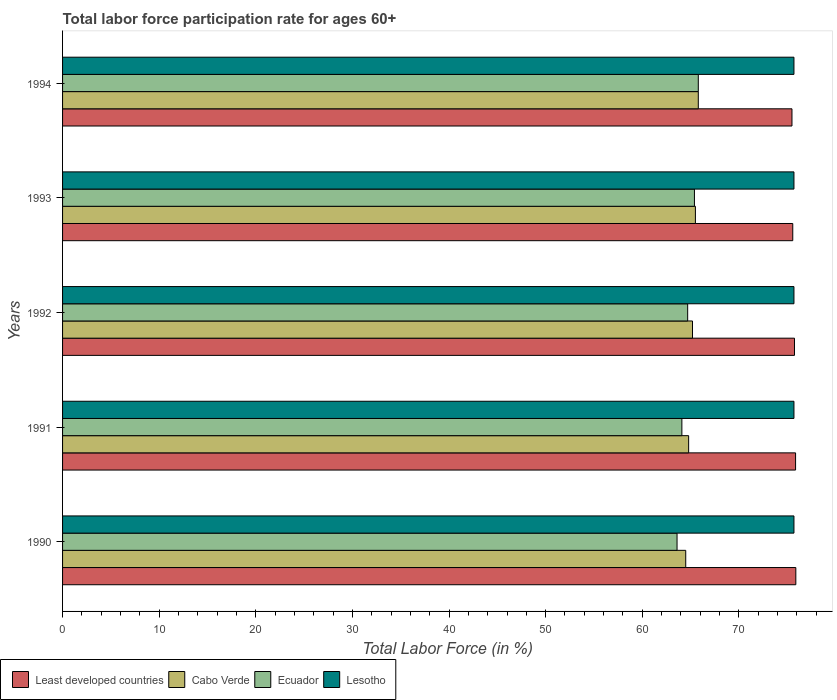How many different coloured bars are there?
Give a very brief answer. 4. How many groups of bars are there?
Your response must be concise. 5. Are the number of bars per tick equal to the number of legend labels?
Give a very brief answer. Yes. How many bars are there on the 1st tick from the top?
Make the answer very short. 4. In how many cases, is the number of bars for a given year not equal to the number of legend labels?
Your answer should be very brief. 0. What is the labor force participation rate in Cabo Verde in 1991?
Your answer should be very brief. 64.8. Across all years, what is the maximum labor force participation rate in Cabo Verde?
Your response must be concise. 65.8. Across all years, what is the minimum labor force participation rate in Lesotho?
Your answer should be very brief. 75.7. In which year was the labor force participation rate in Lesotho maximum?
Your answer should be compact. 1990. In which year was the labor force participation rate in Ecuador minimum?
Offer a very short reply. 1990. What is the total labor force participation rate in Ecuador in the graph?
Your answer should be compact. 323.6. What is the difference between the labor force participation rate in Lesotho in 1991 and that in 1992?
Your answer should be compact. 0. What is the difference between the labor force participation rate in Least developed countries in 1992 and the labor force participation rate in Lesotho in 1991?
Provide a succinct answer. 0.05. What is the average labor force participation rate in Least developed countries per year?
Ensure brevity in your answer.  75.72. In the year 1993, what is the difference between the labor force participation rate in Lesotho and labor force participation rate in Least developed countries?
Offer a very short reply. 0.12. What is the ratio of the labor force participation rate in Ecuador in 1990 to that in 1991?
Offer a very short reply. 0.99. Is the labor force participation rate in Ecuador in 1990 less than that in 1994?
Offer a terse response. Yes. Is the difference between the labor force participation rate in Lesotho in 1991 and 1992 greater than the difference between the labor force participation rate in Least developed countries in 1991 and 1992?
Your answer should be very brief. No. What is the difference between the highest and the second highest labor force participation rate in Ecuador?
Your answer should be very brief. 0.4. What is the difference between the highest and the lowest labor force participation rate in Ecuador?
Offer a very short reply. 2.2. Is it the case that in every year, the sum of the labor force participation rate in Ecuador and labor force participation rate in Least developed countries is greater than the sum of labor force participation rate in Lesotho and labor force participation rate in Cabo Verde?
Your response must be concise. No. What does the 1st bar from the top in 1991 represents?
Provide a succinct answer. Lesotho. What does the 4th bar from the bottom in 1991 represents?
Keep it short and to the point. Lesotho. Is it the case that in every year, the sum of the labor force participation rate in Cabo Verde and labor force participation rate in Least developed countries is greater than the labor force participation rate in Lesotho?
Offer a terse response. Yes. Are all the bars in the graph horizontal?
Give a very brief answer. Yes. How many years are there in the graph?
Provide a short and direct response. 5. What is the difference between two consecutive major ticks on the X-axis?
Offer a terse response. 10. What is the title of the graph?
Provide a short and direct response. Total labor force participation rate for ages 60+. What is the label or title of the Y-axis?
Offer a very short reply. Years. What is the Total Labor Force (in %) of Least developed countries in 1990?
Offer a terse response. 75.89. What is the Total Labor Force (in %) of Cabo Verde in 1990?
Provide a short and direct response. 64.5. What is the Total Labor Force (in %) in Ecuador in 1990?
Your response must be concise. 63.6. What is the Total Labor Force (in %) in Lesotho in 1990?
Your answer should be very brief. 75.7. What is the Total Labor Force (in %) in Least developed countries in 1991?
Give a very brief answer. 75.87. What is the Total Labor Force (in %) in Cabo Verde in 1991?
Provide a succinct answer. 64.8. What is the Total Labor Force (in %) of Ecuador in 1991?
Keep it short and to the point. 64.1. What is the Total Labor Force (in %) of Lesotho in 1991?
Make the answer very short. 75.7. What is the Total Labor Force (in %) of Least developed countries in 1992?
Offer a terse response. 75.75. What is the Total Labor Force (in %) in Cabo Verde in 1992?
Your answer should be compact. 65.2. What is the Total Labor Force (in %) of Ecuador in 1992?
Your response must be concise. 64.7. What is the Total Labor Force (in %) in Lesotho in 1992?
Make the answer very short. 75.7. What is the Total Labor Force (in %) of Least developed countries in 1993?
Make the answer very short. 75.58. What is the Total Labor Force (in %) of Cabo Verde in 1993?
Make the answer very short. 65.5. What is the Total Labor Force (in %) of Ecuador in 1993?
Offer a terse response. 65.4. What is the Total Labor Force (in %) of Lesotho in 1993?
Provide a succinct answer. 75.7. What is the Total Labor Force (in %) in Least developed countries in 1994?
Your response must be concise. 75.49. What is the Total Labor Force (in %) of Cabo Verde in 1994?
Provide a short and direct response. 65.8. What is the Total Labor Force (in %) in Ecuador in 1994?
Keep it short and to the point. 65.8. What is the Total Labor Force (in %) of Lesotho in 1994?
Make the answer very short. 75.7. Across all years, what is the maximum Total Labor Force (in %) in Least developed countries?
Keep it short and to the point. 75.89. Across all years, what is the maximum Total Labor Force (in %) in Cabo Verde?
Your answer should be compact. 65.8. Across all years, what is the maximum Total Labor Force (in %) of Ecuador?
Provide a succinct answer. 65.8. Across all years, what is the maximum Total Labor Force (in %) in Lesotho?
Offer a terse response. 75.7. Across all years, what is the minimum Total Labor Force (in %) of Least developed countries?
Provide a short and direct response. 75.49. Across all years, what is the minimum Total Labor Force (in %) of Cabo Verde?
Keep it short and to the point. 64.5. Across all years, what is the minimum Total Labor Force (in %) in Ecuador?
Provide a succinct answer. 63.6. Across all years, what is the minimum Total Labor Force (in %) of Lesotho?
Ensure brevity in your answer.  75.7. What is the total Total Labor Force (in %) in Least developed countries in the graph?
Your answer should be compact. 378.59. What is the total Total Labor Force (in %) of Cabo Verde in the graph?
Your answer should be very brief. 325.8. What is the total Total Labor Force (in %) in Ecuador in the graph?
Offer a terse response. 323.6. What is the total Total Labor Force (in %) of Lesotho in the graph?
Offer a terse response. 378.5. What is the difference between the Total Labor Force (in %) in Least developed countries in 1990 and that in 1991?
Provide a succinct answer. 0.03. What is the difference between the Total Labor Force (in %) in Cabo Verde in 1990 and that in 1991?
Keep it short and to the point. -0.3. What is the difference between the Total Labor Force (in %) of Least developed countries in 1990 and that in 1992?
Your response must be concise. 0.14. What is the difference between the Total Labor Force (in %) in Ecuador in 1990 and that in 1992?
Provide a short and direct response. -1.1. What is the difference between the Total Labor Force (in %) in Lesotho in 1990 and that in 1992?
Provide a short and direct response. 0. What is the difference between the Total Labor Force (in %) in Least developed countries in 1990 and that in 1993?
Ensure brevity in your answer.  0.32. What is the difference between the Total Labor Force (in %) of Lesotho in 1990 and that in 1993?
Give a very brief answer. 0. What is the difference between the Total Labor Force (in %) of Cabo Verde in 1990 and that in 1994?
Keep it short and to the point. -1.3. What is the difference between the Total Labor Force (in %) of Least developed countries in 1991 and that in 1992?
Your response must be concise. 0.11. What is the difference between the Total Labor Force (in %) in Cabo Verde in 1991 and that in 1992?
Provide a short and direct response. -0.4. What is the difference between the Total Labor Force (in %) in Lesotho in 1991 and that in 1992?
Your answer should be very brief. 0. What is the difference between the Total Labor Force (in %) in Least developed countries in 1991 and that in 1993?
Your answer should be very brief. 0.29. What is the difference between the Total Labor Force (in %) in Ecuador in 1991 and that in 1993?
Give a very brief answer. -1.3. What is the difference between the Total Labor Force (in %) in Least developed countries in 1991 and that in 1994?
Offer a very short reply. 0.37. What is the difference between the Total Labor Force (in %) of Least developed countries in 1992 and that in 1993?
Ensure brevity in your answer.  0.18. What is the difference between the Total Labor Force (in %) of Least developed countries in 1992 and that in 1994?
Your response must be concise. 0.26. What is the difference between the Total Labor Force (in %) of Ecuador in 1992 and that in 1994?
Ensure brevity in your answer.  -1.1. What is the difference between the Total Labor Force (in %) in Lesotho in 1992 and that in 1994?
Provide a succinct answer. 0. What is the difference between the Total Labor Force (in %) of Least developed countries in 1993 and that in 1994?
Keep it short and to the point. 0.08. What is the difference between the Total Labor Force (in %) of Cabo Verde in 1993 and that in 1994?
Offer a terse response. -0.3. What is the difference between the Total Labor Force (in %) of Ecuador in 1993 and that in 1994?
Your response must be concise. -0.4. What is the difference between the Total Labor Force (in %) in Lesotho in 1993 and that in 1994?
Give a very brief answer. 0. What is the difference between the Total Labor Force (in %) of Least developed countries in 1990 and the Total Labor Force (in %) of Cabo Verde in 1991?
Provide a succinct answer. 11.09. What is the difference between the Total Labor Force (in %) in Least developed countries in 1990 and the Total Labor Force (in %) in Ecuador in 1991?
Provide a succinct answer. 11.79. What is the difference between the Total Labor Force (in %) of Least developed countries in 1990 and the Total Labor Force (in %) of Lesotho in 1991?
Give a very brief answer. 0.19. What is the difference between the Total Labor Force (in %) of Cabo Verde in 1990 and the Total Labor Force (in %) of Lesotho in 1991?
Give a very brief answer. -11.2. What is the difference between the Total Labor Force (in %) of Ecuador in 1990 and the Total Labor Force (in %) of Lesotho in 1991?
Offer a terse response. -12.1. What is the difference between the Total Labor Force (in %) of Least developed countries in 1990 and the Total Labor Force (in %) of Cabo Verde in 1992?
Make the answer very short. 10.69. What is the difference between the Total Labor Force (in %) of Least developed countries in 1990 and the Total Labor Force (in %) of Ecuador in 1992?
Provide a succinct answer. 11.19. What is the difference between the Total Labor Force (in %) of Least developed countries in 1990 and the Total Labor Force (in %) of Lesotho in 1992?
Your answer should be compact. 0.19. What is the difference between the Total Labor Force (in %) of Cabo Verde in 1990 and the Total Labor Force (in %) of Lesotho in 1992?
Make the answer very short. -11.2. What is the difference between the Total Labor Force (in %) of Ecuador in 1990 and the Total Labor Force (in %) of Lesotho in 1992?
Give a very brief answer. -12.1. What is the difference between the Total Labor Force (in %) of Least developed countries in 1990 and the Total Labor Force (in %) of Cabo Verde in 1993?
Your answer should be very brief. 10.39. What is the difference between the Total Labor Force (in %) in Least developed countries in 1990 and the Total Labor Force (in %) in Ecuador in 1993?
Provide a short and direct response. 10.49. What is the difference between the Total Labor Force (in %) of Least developed countries in 1990 and the Total Labor Force (in %) of Lesotho in 1993?
Offer a very short reply. 0.19. What is the difference between the Total Labor Force (in %) in Cabo Verde in 1990 and the Total Labor Force (in %) in Ecuador in 1993?
Your response must be concise. -0.9. What is the difference between the Total Labor Force (in %) in Cabo Verde in 1990 and the Total Labor Force (in %) in Lesotho in 1993?
Offer a very short reply. -11.2. What is the difference between the Total Labor Force (in %) in Least developed countries in 1990 and the Total Labor Force (in %) in Cabo Verde in 1994?
Give a very brief answer. 10.09. What is the difference between the Total Labor Force (in %) in Least developed countries in 1990 and the Total Labor Force (in %) in Ecuador in 1994?
Ensure brevity in your answer.  10.09. What is the difference between the Total Labor Force (in %) of Least developed countries in 1990 and the Total Labor Force (in %) of Lesotho in 1994?
Give a very brief answer. 0.19. What is the difference between the Total Labor Force (in %) in Cabo Verde in 1990 and the Total Labor Force (in %) in Lesotho in 1994?
Offer a terse response. -11.2. What is the difference between the Total Labor Force (in %) in Least developed countries in 1991 and the Total Labor Force (in %) in Cabo Verde in 1992?
Give a very brief answer. 10.67. What is the difference between the Total Labor Force (in %) in Least developed countries in 1991 and the Total Labor Force (in %) in Ecuador in 1992?
Offer a very short reply. 11.17. What is the difference between the Total Labor Force (in %) of Least developed countries in 1991 and the Total Labor Force (in %) of Lesotho in 1992?
Provide a succinct answer. 0.17. What is the difference between the Total Labor Force (in %) in Cabo Verde in 1991 and the Total Labor Force (in %) in Lesotho in 1992?
Offer a very short reply. -10.9. What is the difference between the Total Labor Force (in %) of Least developed countries in 1991 and the Total Labor Force (in %) of Cabo Verde in 1993?
Your response must be concise. 10.37. What is the difference between the Total Labor Force (in %) in Least developed countries in 1991 and the Total Labor Force (in %) in Ecuador in 1993?
Give a very brief answer. 10.47. What is the difference between the Total Labor Force (in %) in Least developed countries in 1991 and the Total Labor Force (in %) in Lesotho in 1993?
Give a very brief answer. 0.17. What is the difference between the Total Labor Force (in %) of Cabo Verde in 1991 and the Total Labor Force (in %) of Lesotho in 1993?
Make the answer very short. -10.9. What is the difference between the Total Labor Force (in %) of Least developed countries in 1991 and the Total Labor Force (in %) of Cabo Verde in 1994?
Offer a very short reply. 10.07. What is the difference between the Total Labor Force (in %) of Least developed countries in 1991 and the Total Labor Force (in %) of Ecuador in 1994?
Offer a terse response. 10.07. What is the difference between the Total Labor Force (in %) of Least developed countries in 1991 and the Total Labor Force (in %) of Lesotho in 1994?
Provide a short and direct response. 0.17. What is the difference between the Total Labor Force (in %) of Cabo Verde in 1991 and the Total Labor Force (in %) of Ecuador in 1994?
Offer a very short reply. -1. What is the difference between the Total Labor Force (in %) in Least developed countries in 1992 and the Total Labor Force (in %) in Cabo Verde in 1993?
Your response must be concise. 10.25. What is the difference between the Total Labor Force (in %) of Least developed countries in 1992 and the Total Labor Force (in %) of Ecuador in 1993?
Make the answer very short. 10.35. What is the difference between the Total Labor Force (in %) in Least developed countries in 1992 and the Total Labor Force (in %) in Lesotho in 1993?
Provide a succinct answer. 0.05. What is the difference between the Total Labor Force (in %) of Cabo Verde in 1992 and the Total Labor Force (in %) of Lesotho in 1993?
Your answer should be compact. -10.5. What is the difference between the Total Labor Force (in %) of Least developed countries in 1992 and the Total Labor Force (in %) of Cabo Verde in 1994?
Your answer should be very brief. 9.95. What is the difference between the Total Labor Force (in %) in Least developed countries in 1992 and the Total Labor Force (in %) in Ecuador in 1994?
Offer a very short reply. 9.95. What is the difference between the Total Labor Force (in %) of Least developed countries in 1992 and the Total Labor Force (in %) of Lesotho in 1994?
Provide a succinct answer. 0.05. What is the difference between the Total Labor Force (in %) in Cabo Verde in 1992 and the Total Labor Force (in %) in Ecuador in 1994?
Your answer should be compact. -0.6. What is the difference between the Total Labor Force (in %) in Cabo Verde in 1992 and the Total Labor Force (in %) in Lesotho in 1994?
Your answer should be very brief. -10.5. What is the difference between the Total Labor Force (in %) in Ecuador in 1992 and the Total Labor Force (in %) in Lesotho in 1994?
Your response must be concise. -11. What is the difference between the Total Labor Force (in %) in Least developed countries in 1993 and the Total Labor Force (in %) in Cabo Verde in 1994?
Offer a very short reply. 9.78. What is the difference between the Total Labor Force (in %) of Least developed countries in 1993 and the Total Labor Force (in %) of Ecuador in 1994?
Keep it short and to the point. 9.78. What is the difference between the Total Labor Force (in %) in Least developed countries in 1993 and the Total Labor Force (in %) in Lesotho in 1994?
Give a very brief answer. -0.12. What is the difference between the Total Labor Force (in %) in Cabo Verde in 1993 and the Total Labor Force (in %) in Ecuador in 1994?
Make the answer very short. -0.3. What is the difference between the Total Labor Force (in %) of Ecuador in 1993 and the Total Labor Force (in %) of Lesotho in 1994?
Your answer should be compact. -10.3. What is the average Total Labor Force (in %) in Least developed countries per year?
Provide a short and direct response. 75.72. What is the average Total Labor Force (in %) of Cabo Verde per year?
Provide a succinct answer. 65.16. What is the average Total Labor Force (in %) in Ecuador per year?
Your answer should be compact. 64.72. What is the average Total Labor Force (in %) of Lesotho per year?
Make the answer very short. 75.7. In the year 1990, what is the difference between the Total Labor Force (in %) in Least developed countries and Total Labor Force (in %) in Cabo Verde?
Make the answer very short. 11.39. In the year 1990, what is the difference between the Total Labor Force (in %) of Least developed countries and Total Labor Force (in %) of Ecuador?
Your answer should be compact. 12.29. In the year 1990, what is the difference between the Total Labor Force (in %) in Least developed countries and Total Labor Force (in %) in Lesotho?
Give a very brief answer. 0.19. In the year 1990, what is the difference between the Total Labor Force (in %) in Cabo Verde and Total Labor Force (in %) in Ecuador?
Provide a short and direct response. 0.9. In the year 1991, what is the difference between the Total Labor Force (in %) of Least developed countries and Total Labor Force (in %) of Cabo Verde?
Give a very brief answer. 11.07. In the year 1991, what is the difference between the Total Labor Force (in %) in Least developed countries and Total Labor Force (in %) in Ecuador?
Offer a terse response. 11.77. In the year 1991, what is the difference between the Total Labor Force (in %) in Least developed countries and Total Labor Force (in %) in Lesotho?
Ensure brevity in your answer.  0.17. In the year 1991, what is the difference between the Total Labor Force (in %) of Cabo Verde and Total Labor Force (in %) of Ecuador?
Make the answer very short. 0.7. In the year 1992, what is the difference between the Total Labor Force (in %) of Least developed countries and Total Labor Force (in %) of Cabo Verde?
Keep it short and to the point. 10.55. In the year 1992, what is the difference between the Total Labor Force (in %) of Least developed countries and Total Labor Force (in %) of Ecuador?
Provide a short and direct response. 11.05. In the year 1992, what is the difference between the Total Labor Force (in %) in Least developed countries and Total Labor Force (in %) in Lesotho?
Ensure brevity in your answer.  0.05. In the year 1993, what is the difference between the Total Labor Force (in %) of Least developed countries and Total Labor Force (in %) of Cabo Verde?
Give a very brief answer. 10.08. In the year 1993, what is the difference between the Total Labor Force (in %) in Least developed countries and Total Labor Force (in %) in Ecuador?
Make the answer very short. 10.18. In the year 1993, what is the difference between the Total Labor Force (in %) in Least developed countries and Total Labor Force (in %) in Lesotho?
Provide a succinct answer. -0.12. In the year 1994, what is the difference between the Total Labor Force (in %) in Least developed countries and Total Labor Force (in %) in Cabo Verde?
Provide a succinct answer. 9.69. In the year 1994, what is the difference between the Total Labor Force (in %) in Least developed countries and Total Labor Force (in %) in Ecuador?
Provide a succinct answer. 9.69. In the year 1994, what is the difference between the Total Labor Force (in %) of Least developed countries and Total Labor Force (in %) of Lesotho?
Make the answer very short. -0.21. In the year 1994, what is the difference between the Total Labor Force (in %) of Cabo Verde and Total Labor Force (in %) of Ecuador?
Provide a short and direct response. 0. In the year 1994, what is the difference between the Total Labor Force (in %) in Cabo Verde and Total Labor Force (in %) in Lesotho?
Your answer should be very brief. -9.9. What is the ratio of the Total Labor Force (in %) in Least developed countries in 1990 to that in 1991?
Your answer should be compact. 1. What is the ratio of the Total Labor Force (in %) in Cabo Verde in 1990 to that in 1991?
Give a very brief answer. 1. What is the ratio of the Total Labor Force (in %) of Lesotho in 1990 to that in 1991?
Ensure brevity in your answer.  1. What is the ratio of the Total Labor Force (in %) of Least developed countries in 1990 to that in 1992?
Provide a short and direct response. 1. What is the ratio of the Total Labor Force (in %) of Cabo Verde in 1990 to that in 1992?
Ensure brevity in your answer.  0.99. What is the ratio of the Total Labor Force (in %) in Lesotho in 1990 to that in 1992?
Your answer should be very brief. 1. What is the ratio of the Total Labor Force (in %) in Cabo Verde in 1990 to that in 1993?
Ensure brevity in your answer.  0.98. What is the ratio of the Total Labor Force (in %) of Ecuador in 1990 to that in 1993?
Provide a short and direct response. 0.97. What is the ratio of the Total Labor Force (in %) of Lesotho in 1990 to that in 1993?
Your response must be concise. 1. What is the ratio of the Total Labor Force (in %) in Least developed countries in 1990 to that in 1994?
Ensure brevity in your answer.  1.01. What is the ratio of the Total Labor Force (in %) in Cabo Verde in 1990 to that in 1994?
Make the answer very short. 0.98. What is the ratio of the Total Labor Force (in %) of Ecuador in 1990 to that in 1994?
Provide a succinct answer. 0.97. What is the ratio of the Total Labor Force (in %) in Lesotho in 1990 to that in 1994?
Offer a very short reply. 1. What is the ratio of the Total Labor Force (in %) in Cabo Verde in 1991 to that in 1992?
Give a very brief answer. 0.99. What is the ratio of the Total Labor Force (in %) in Lesotho in 1991 to that in 1992?
Make the answer very short. 1. What is the ratio of the Total Labor Force (in %) of Cabo Verde in 1991 to that in 1993?
Keep it short and to the point. 0.99. What is the ratio of the Total Labor Force (in %) in Ecuador in 1991 to that in 1993?
Your answer should be very brief. 0.98. What is the ratio of the Total Labor Force (in %) of Lesotho in 1991 to that in 1993?
Your answer should be compact. 1. What is the ratio of the Total Labor Force (in %) of Ecuador in 1991 to that in 1994?
Keep it short and to the point. 0.97. What is the ratio of the Total Labor Force (in %) of Lesotho in 1991 to that in 1994?
Your response must be concise. 1. What is the ratio of the Total Labor Force (in %) of Least developed countries in 1992 to that in 1993?
Ensure brevity in your answer.  1. What is the ratio of the Total Labor Force (in %) of Cabo Verde in 1992 to that in 1993?
Give a very brief answer. 1. What is the ratio of the Total Labor Force (in %) in Ecuador in 1992 to that in 1993?
Provide a short and direct response. 0.99. What is the ratio of the Total Labor Force (in %) of Least developed countries in 1992 to that in 1994?
Make the answer very short. 1. What is the ratio of the Total Labor Force (in %) in Cabo Verde in 1992 to that in 1994?
Ensure brevity in your answer.  0.99. What is the ratio of the Total Labor Force (in %) of Ecuador in 1992 to that in 1994?
Make the answer very short. 0.98. What is the ratio of the Total Labor Force (in %) of Ecuador in 1993 to that in 1994?
Give a very brief answer. 0.99. What is the ratio of the Total Labor Force (in %) of Lesotho in 1993 to that in 1994?
Offer a terse response. 1. What is the difference between the highest and the second highest Total Labor Force (in %) of Least developed countries?
Your answer should be very brief. 0.03. What is the difference between the highest and the second highest Total Labor Force (in %) in Cabo Verde?
Keep it short and to the point. 0.3. What is the difference between the highest and the second highest Total Labor Force (in %) in Ecuador?
Make the answer very short. 0.4. What is the difference between the highest and the lowest Total Labor Force (in %) of Least developed countries?
Provide a succinct answer. 0.4. What is the difference between the highest and the lowest Total Labor Force (in %) in Ecuador?
Make the answer very short. 2.2. 